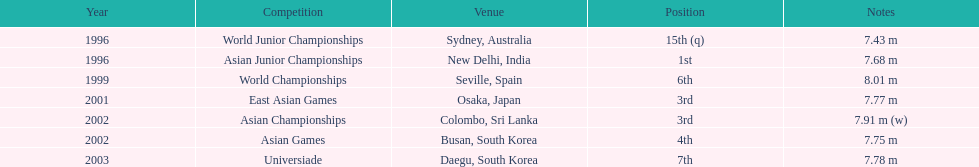What were the contests huang le took part in? World Junior Championships, Asian Junior Championships, World Championships, East Asian Games, Asian Championships, Asian Games, Universiade. What were his accomplishments in terms of distances in these contests? 7.43 m, 7.68 m, 8.01 m, 7.77 m, 7.91 m (w), 7.75 m, 7.78 m. Which of these accomplishments was the farthest? 7.91 m (w). 